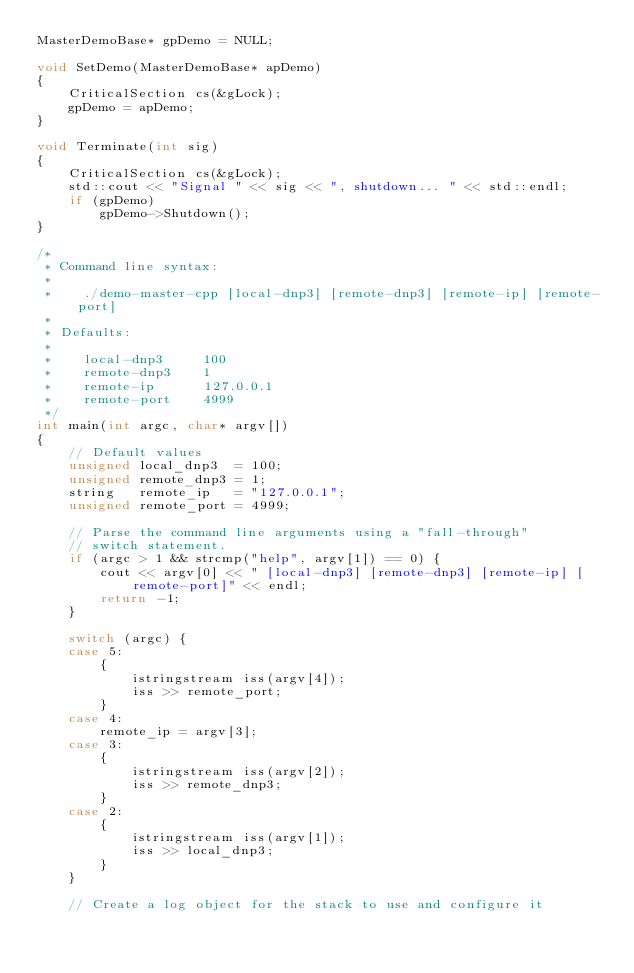Convert code to text. <code><loc_0><loc_0><loc_500><loc_500><_C++_>MasterDemoBase* gpDemo = NULL;

void SetDemo(MasterDemoBase* apDemo)
{
	CriticalSection cs(&gLock);
	gpDemo = apDemo;
}

void Terminate(int sig)
{
	CriticalSection cs(&gLock);
	std::cout << "Signal " << sig << ", shutdown... " << std::endl;
	if (gpDemo)
		gpDemo->Shutdown();
}

/*
 * Command line syntax:
 *
 *    ./demo-master-cpp [local-dnp3] [remote-dnp3] [remote-ip] [remote-port]
 *
 * Defaults:
 *
 *    local-dnp3     100
 *    remote-dnp3    1
 *    remote-ip      127.0.0.1
 *    remote-port    4999
 */
int main(int argc, char* argv[])
{
	// Default values
	unsigned local_dnp3  = 100;
	unsigned remote_dnp3 = 1;
	string   remote_ip   = "127.0.0.1";
	unsigned remote_port = 4999;

	// Parse the command line arguments using a "fall-through"
	// switch statement.
	if (argc > 1 && strcmp("help", argv[1]) == 0) {
		cout << argv[0] << " [local-dnp3] [remote-dnp3] [remote-ip] [remote-port]" << endl;
		return -1;
	}

	switch (argc) {
	case 5:
		{
			istringstream iss(argv[4]);
			iss >> remote_port;
		}
	case 4:
		remote_ip = argv[3];
	case 3:
		{
			istringstream iss(argv[2]);
			iss >> remote_dnp3;
		}
	case 2:
		{
			istringstream iss(argv[1]);
			iss >> local_dnp3;
		}
	}

	// Create a log object for the stack to use and configure it</code> 